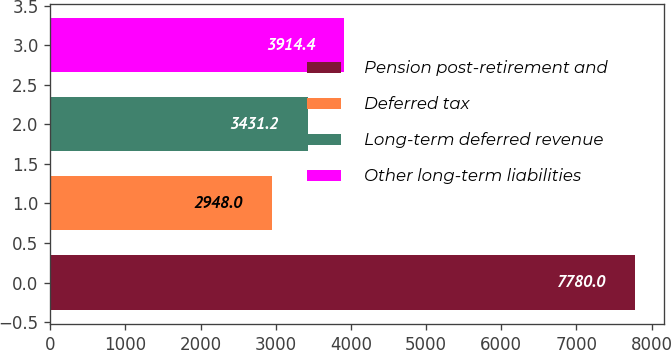Convert chart to OTSL. <chart><loc_0><loc_0><loc_500><loc_500><bar_chart><fcel>Pension post-retirement and<fcel>Deferred tax<fcel>Long-term deferred revenue<fcel>Other long-term liabilities<nl><fcel>7780<fcel>2948<fcel>3431.2<fcel>3914.4<nl></chart> 